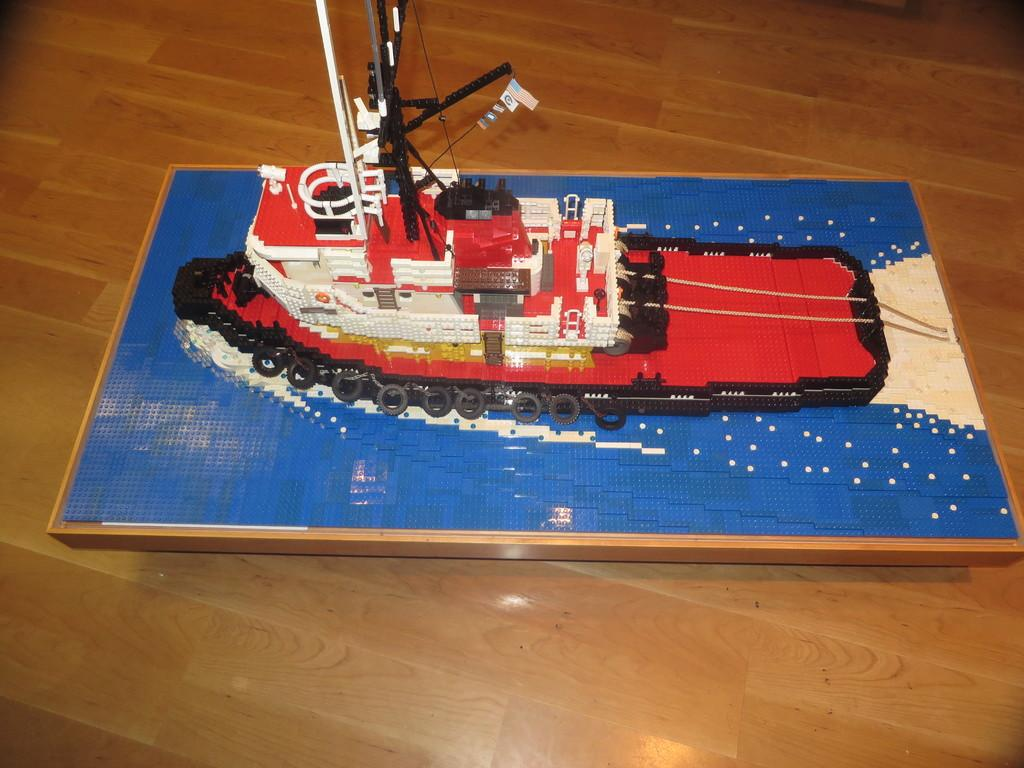What is the main object in the middle of the image? There is a toy ship in the middle of the image. What type of surface is visible at the bottom of the image? There is a wooden surface at the bottom of the image. What type of marble is used to decorate the toy ship in the image? There is no marble present on the toy ship in the image. 